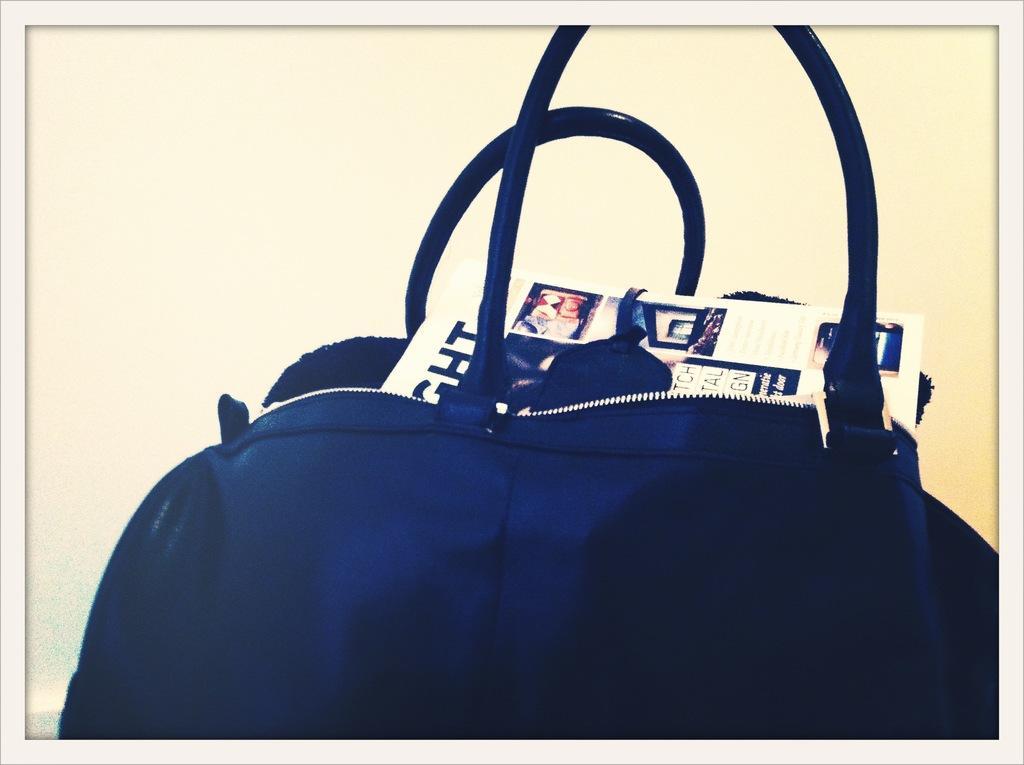How would you summarize this image in a sentence or two? In this image there is a blue color leather handbag in which there are news papers , at the back ground there is a wall. 